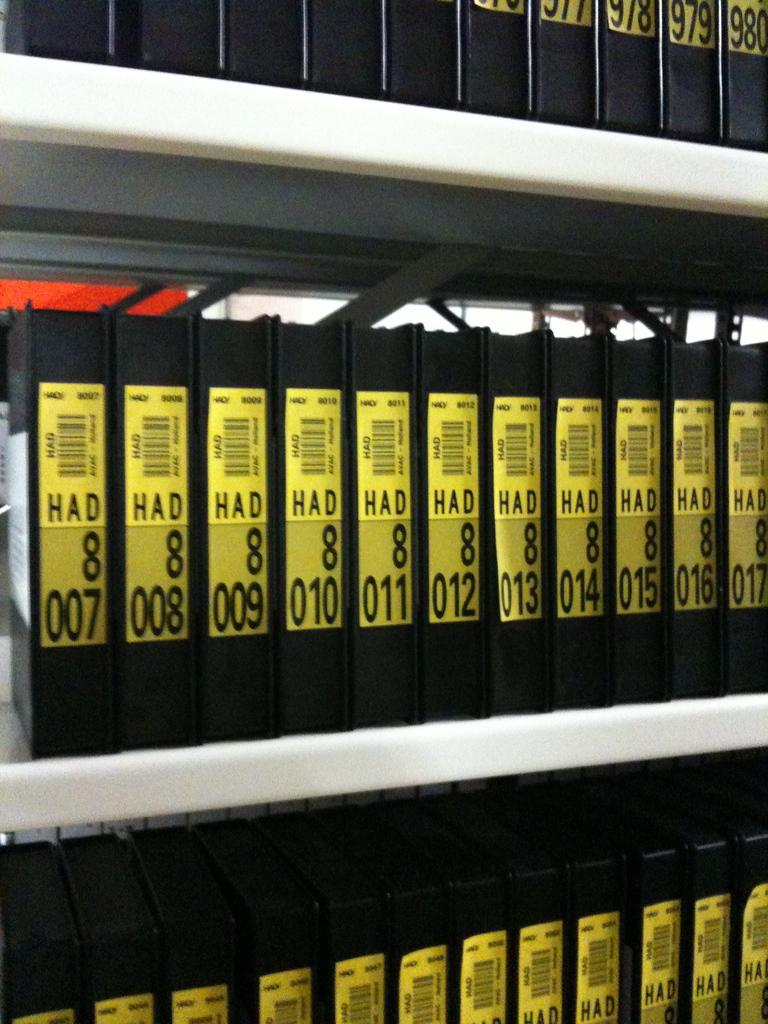<image>
Render a clear and concise summary of the photo. A collection of cases on a shelf includes numbers 007 through 017 on the middle shelf. 